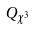<formula> <loc_0><loc_0><loc_500><loc_500>Q _ { \chi ^ { 3 } }</formula> 